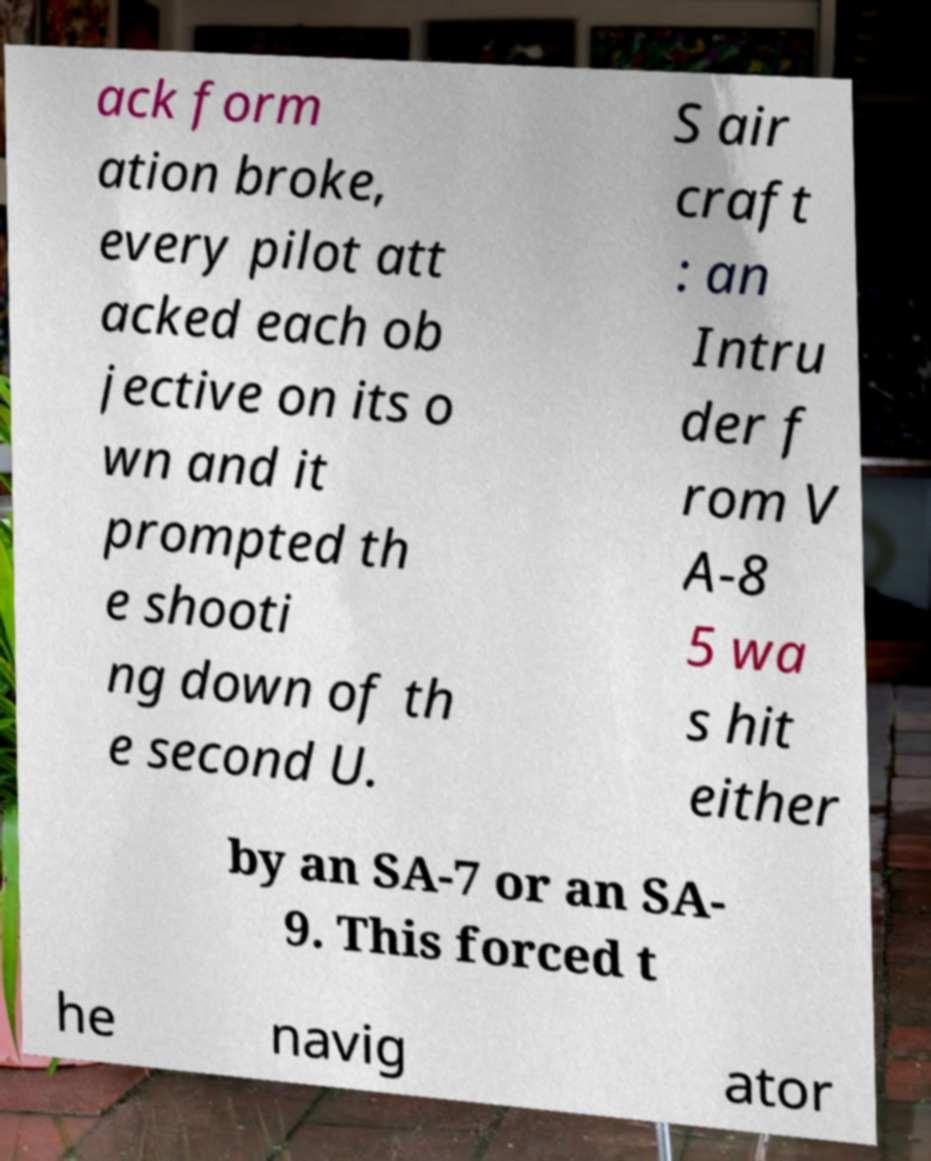Can you accurately transcribe the text from the provided image for me? ack form ation broke, every pilot att acked each ob jective on its o wn and it prompted th e shooti ng down of th e second U. S air craft : an Intru der f rom V A-8 5 wa s hit either by an SA-7 or an SA- 9. This forced t he navig ator 